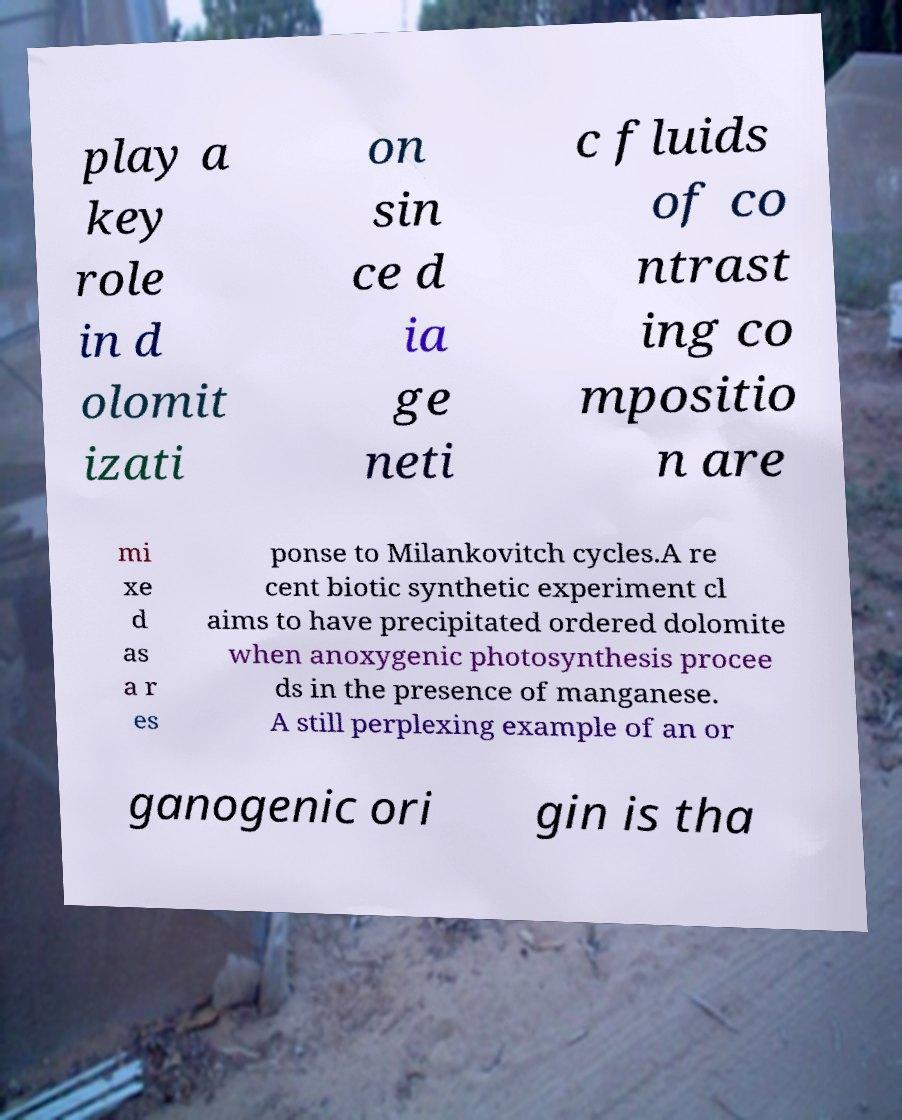Could you extract and type out the text from this image? play a key role in d olomit izati on sin ce d ia ge neti c fluids of co ntrast ing co mpositio n are mi xe d as a r es ponse to Milankovitch cycles.A re cent biotic synthetic experiment cl aims to have precipitated ordered dolomite when anoxygenic photosynthesis procee ds in the presence of manganese. A still perplexing example of an or ganogenic ori gin is tha 